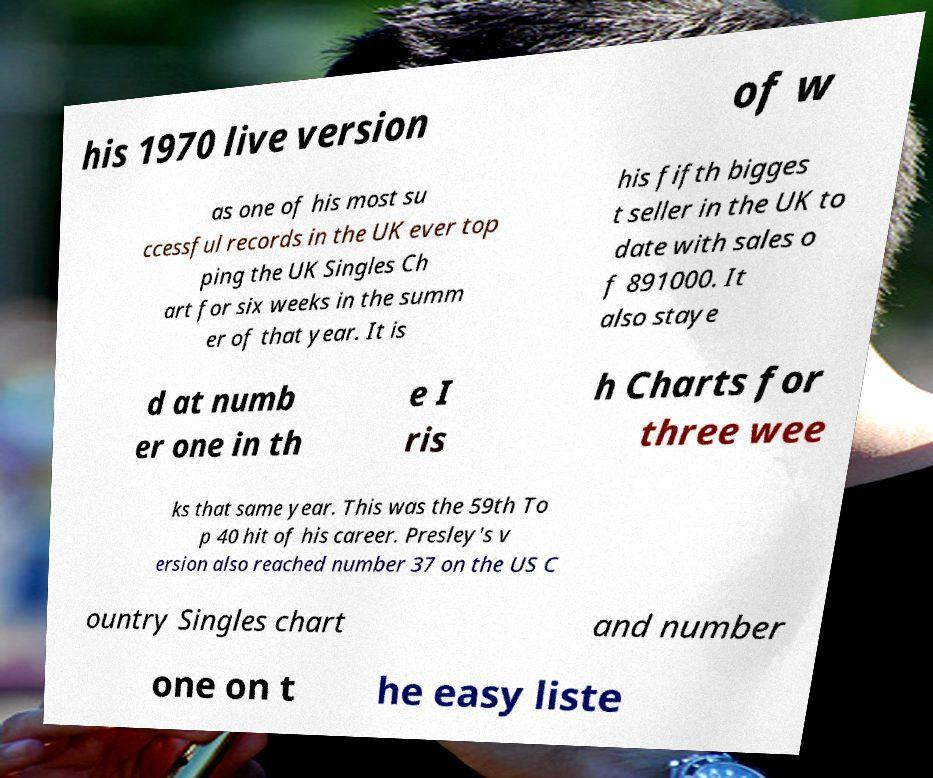What messages or text are displayed in this image? I need them in a readable, typed format. his 1970 live version of w as one of his most su ccessful records in the UK ever top ping the UK Singles Ch art for six weeks in the summ er of that year. It is his fifth bigges t seller in the UK to date with sales o f 891000. It also staye d at numb er one in th e I ris h Charts for three wee ks that same year. This was the 59th To p 40 hit of his career. Presley's v ersion also reached number 37 on the US C ountry Singles chart and number one on t he easy liste 